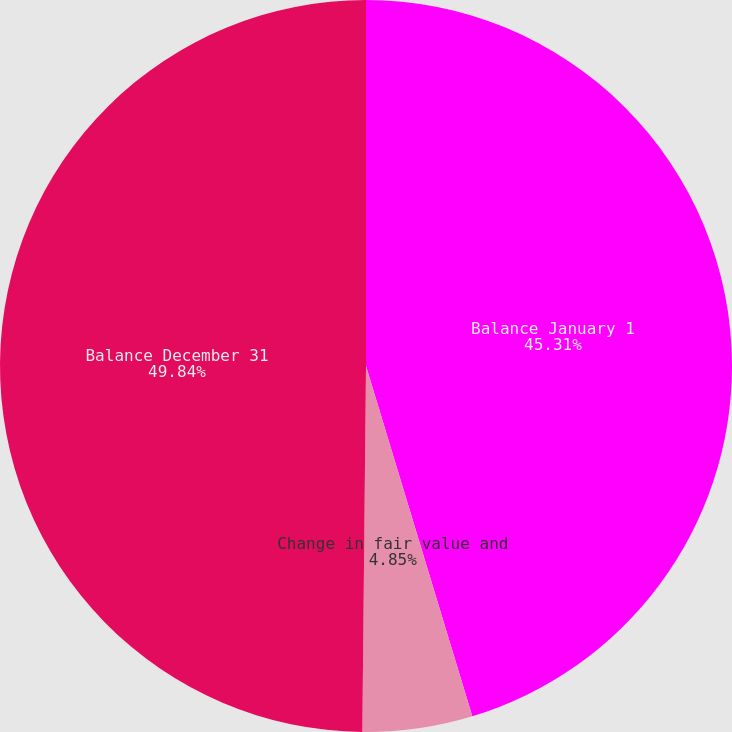Convert chart to OTSL. <chart><loc_0><loc_0><loc_500><loc_500><pie_chart><fcel>Balance January 1<fcel>Change in fair value and<fcel>Balance December 31<nl><fcel>45.31%<fcel>4.85%<fcel>49.84%<nl></chart> 